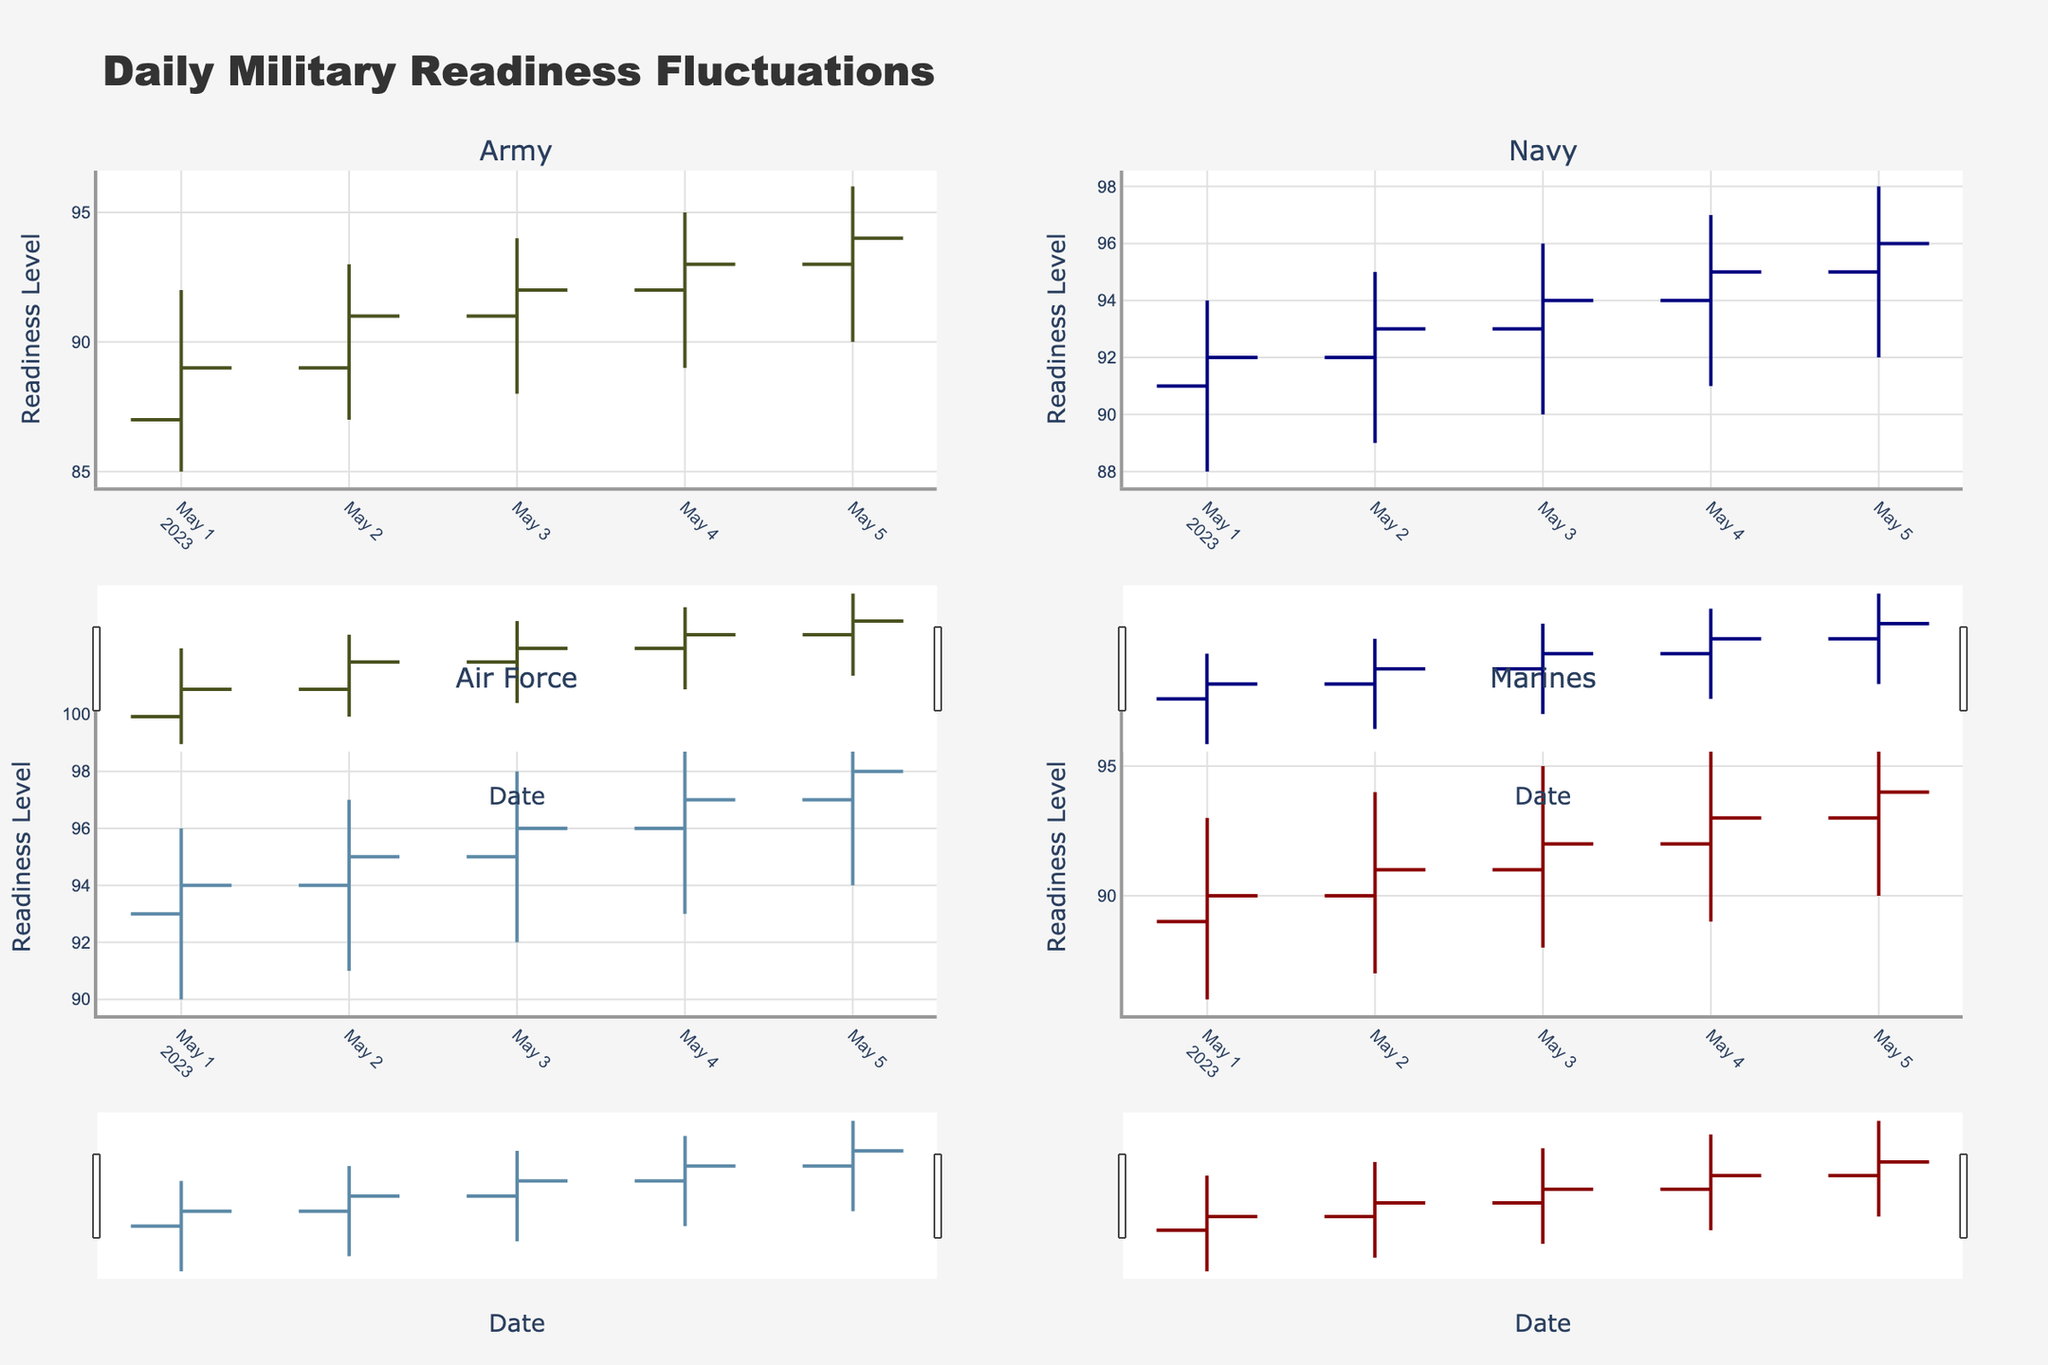What's the title of the figure? The title is prominently located at the top of the figure and provides a summary of what the chart is depicting. The title in this case reads "Daily Military Readiness Fluctuations."
Answer: Daily Military Readiness Fluctuations What's the readiness level of the Navy on May 3rd? To find the readiness level of the Navy on May 3rd, look at the OHLC chart for the Navy. The "Close" value on May 3rd represents the readiness level at the end of the day, which is 94.
Answer: 94 Which branch experienced the highest readiness level on May 1st? Compare the "High" values for all branches on May 1st. The Air Force has the highest value at 96, higher than the others.
Answer: Air Force Did any branch have a decrease in readiness level from May 4th to May 5th? Compare the "Close" values on May 4th and May 5th for each branch. For the Army, the readiness level increased from 93 to 94. For the Navy, it increased from 95 to 96. For the Air Force, it increased from 97 to 98. For the Marines, it increased from 93 to 94. None of the branches experienced a decrease.
Answer: No Which branch had the smallest fluctuation in readiness levels on May 2nd? Fluctuation can be measured as the difference between "High" and "Low" values. For May 2nd's data: Army (93-87 = 6), Navy (95-89 = 6), Air Force (97-91 = 6), Marines (94-87 = 7). The smallest fluctuation is for the Army, Navy, and Air Force with a fluctuation of 6.
Answer: Army, Navy, Air Force On which day did the Marines have the highest "High" value? Look at the "High" values for the Marines across the days. The highest "High" value was recorded on May 5th with 97.
Answer: May 5th How many branches increased their readiness levels from May 3rd to May 4th? Compare the "Close" values on May 3rd and May 4th. For the Army, the readiness level increased from 92 to 93. For the Navy, it increased from 94 to 95. For the Air Force, it increased from 96 to 97. For the Marines, it increased from 92 to 93. All four branches increased their readiness levels.
Answer: 4 Which branch had the highest increase in readiness from May 2nd to May 3rd? Look at the differences between the "Close" values on May 2nd and May 3rd for each branch. The Army increased by 1 (91 to 92), the Navy by 1 (93 to 94), the Air Force by 1 (95 to 96), and the Marines by 1 (91 to 92). Each branch had the same increase of 1.
Answer: All branches had the same increase What's the average "Close" value for the Navy over the provided dates? Sum the "Close" values for the Navy across the dates and divide by the number of dates. (92 + 93 + 94 + 95 + 96) / 5 = 470 / 5 = 94.
Answer: 94 